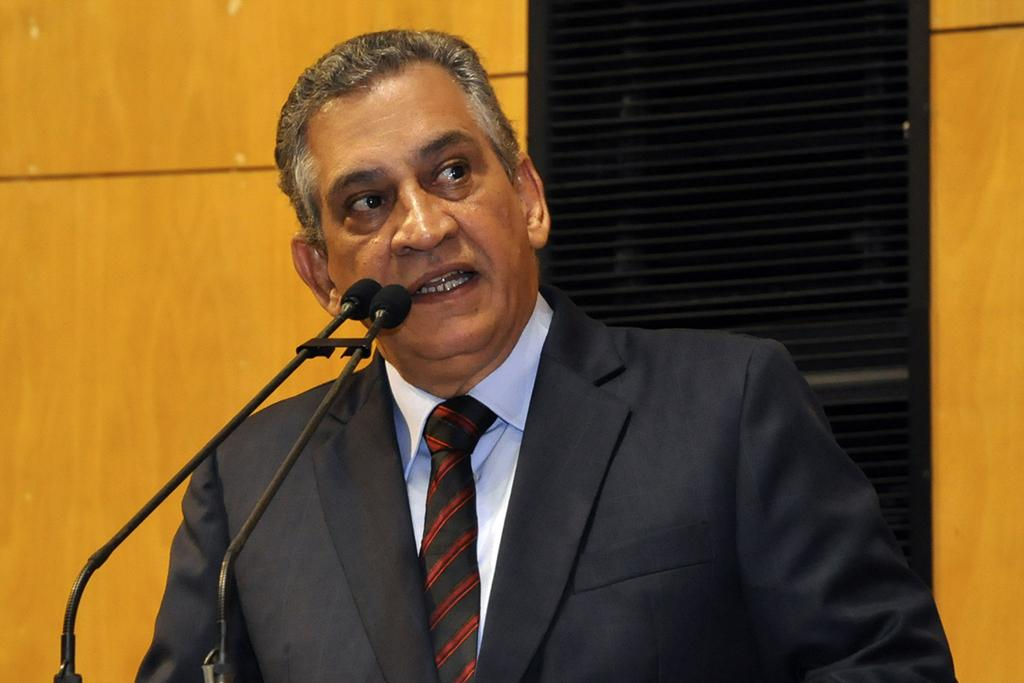Who or what is present in the image? There is a person in the image. What objects can be seen near the person? There are microphones in the image. What type of background is visible in the image? There is a wall in the image. Can you describe the color of any objects in the image? There is a black-colored object in the image. What type of card is being used by the person in the image? There is no card present in the image. What is the engine's make and model in the image? There is no engine present in the image. 